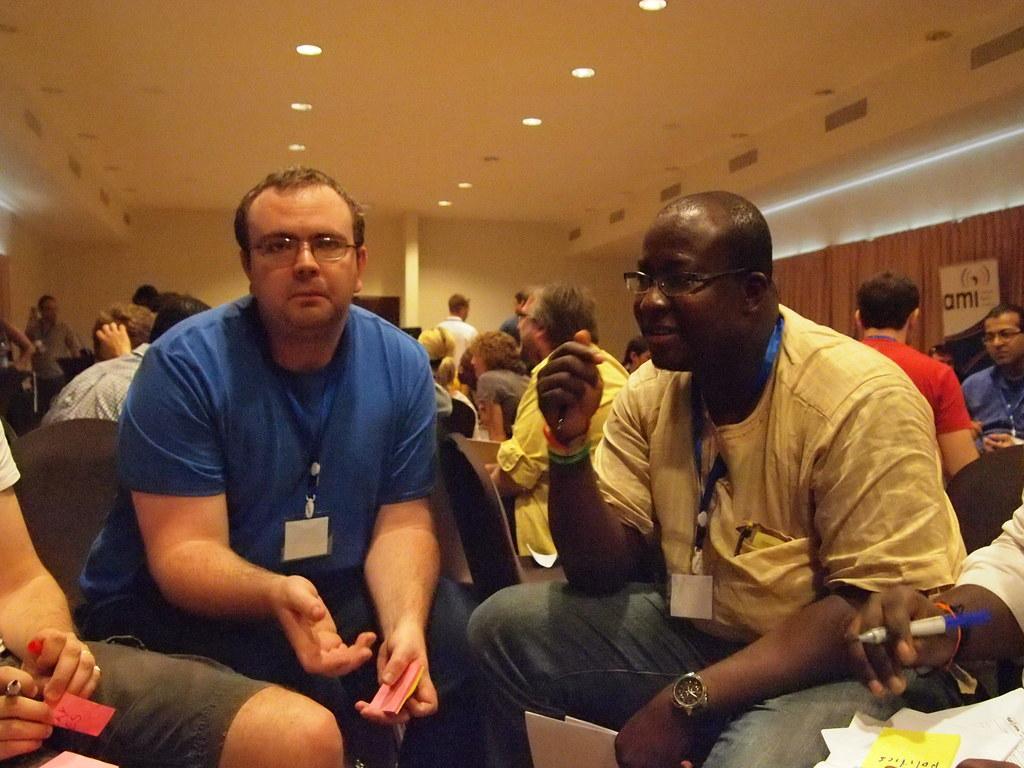Describe this image in one or two sentences. In this image I see number of people in which most of them are sitting on chairs and I see these men are holding something in their hands. In the background I see the wall and I see the lights on the ceiling. 